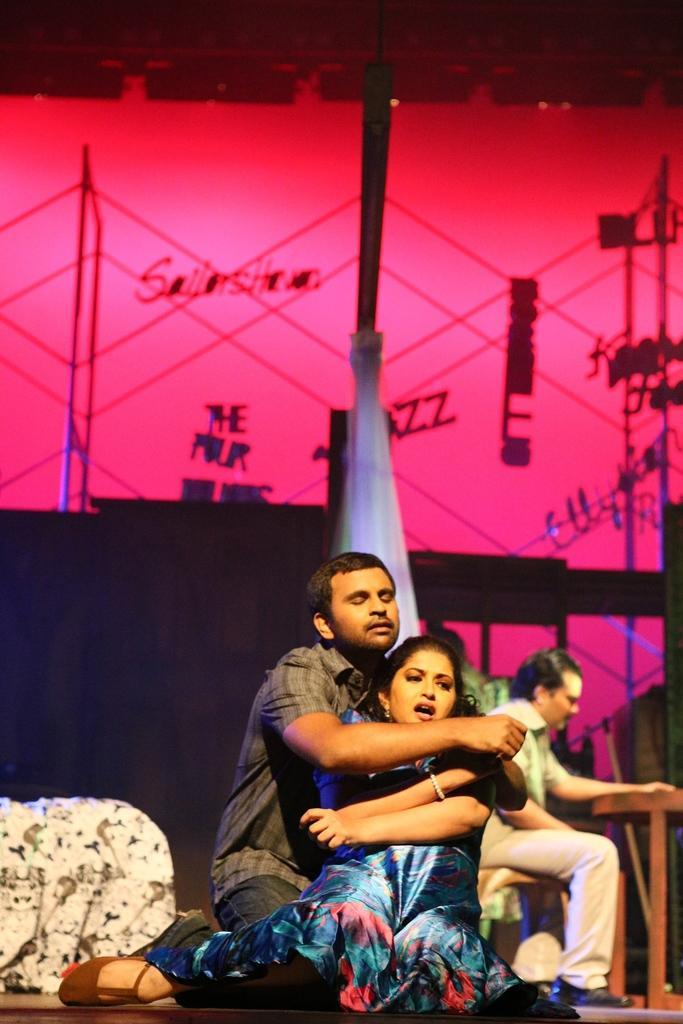How would you summarize this image in a sentence or two? In this image I can see three persons are sitting. On the right side of this image I can see a table and in the background I can see few poles, a pink colour thing and on it I can see something is written. 